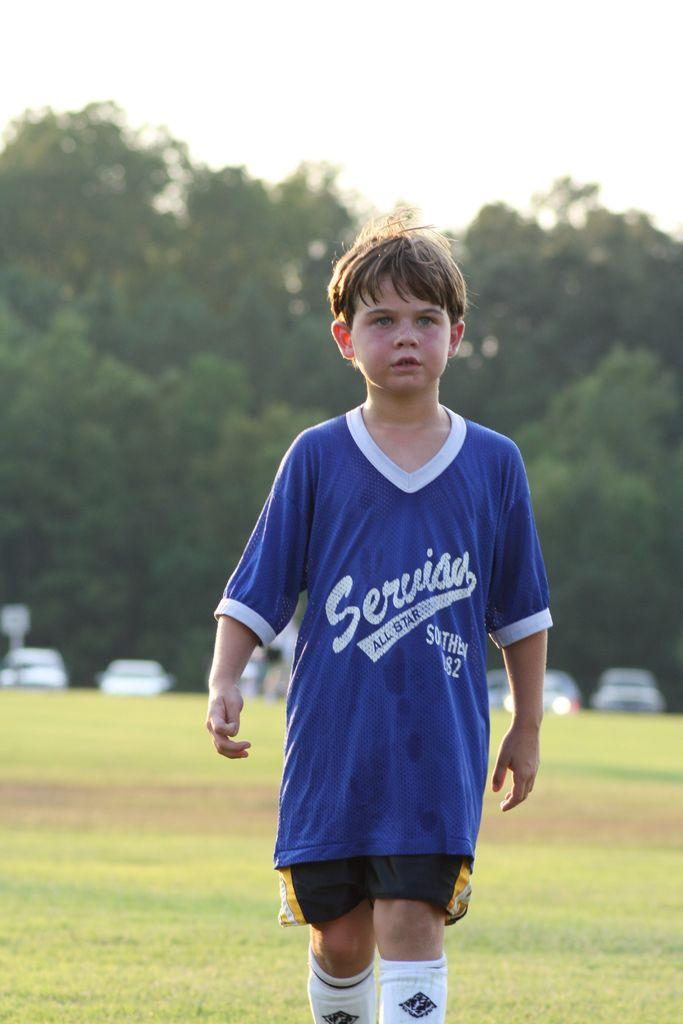Provide a one-sentence caption for the provided image. A child is wearing a blue jersey, representing the Serviau All-Stars. 